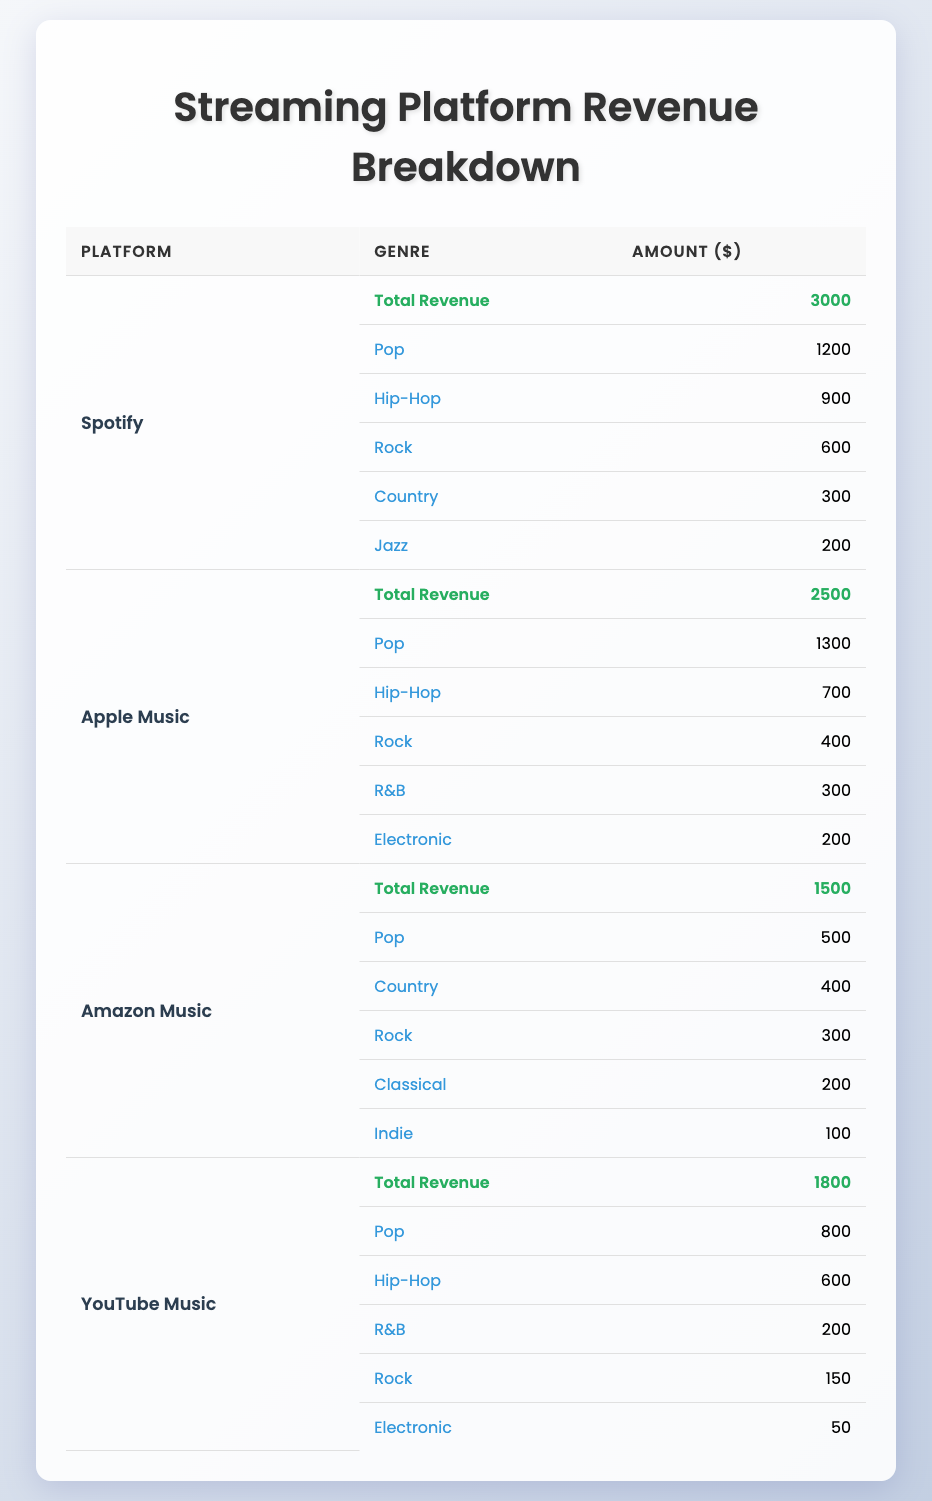What is the total revenue for Spotify? The total revenue for Spotify is listed in the table under the "Total Revenue" row. By checking that specific entry, we see it is 3000.
Answer: 3000 Which platform has the highest revenue from the Pop genre? To find out which platform has the highest revenue for Pop, we compare the Pop revenue figures across all platforms: Spotify (1200), Apple Music (1300), Amazon Music (500), and YouTube Music (800). Apple Music has the highest with 1300.
Answer: Apple Music Is the revenue from Hip-Hop higher on Spotify than on Apple Music? We look at the Hip-Hop revenue figures for both platforms. Spotify earns 900 from Hip-Hop, while Apple Music earns 700. Since 900 is greater than 700, the statement is true.
Answer: Yes What is the total revenue from Rock across all platforms? We need to sum the Rock revenues from each platform: Spotify (600), Apple Music (400), Amazon Music (300), and YouTube Music (150). Adding these gives us 600 + 400 + 300 + 150 = 1450.
Answer: 1450 Does Amazon Music earn more from Country than from Indie? We check the Country revenue (400) and Indie revenue (100) for Amazon Music. Since 400 is greater than 100, the answer is true.
Answer: Yes What is the average revenue generated from the R&B genre across the streaming platforms? The R&B revenue figures are: Apple Music (300) and YouTube Music (200). We add them: 300 + 200 = 500, then divide by the number of platforms (2) to find the average: 500 / 2 = 250.
Answer: 250 Which genre has the lowest revenue on YouTube Music? We look at the YouTube Music genres: Pop (800), Hip-Hop (600), R&B (200), Rock (150), and Electronic (50). The lowest revenue is from the Electronic genre at 50.
Answer: Electronic What is the difference in total revenue between Spotify and Amazon Music? The total revenue for Spotify is 3000 and for Amazon Music is 1500. To find the difference, we subtract: 3000 - 1500 = 1500.
Answer: 1500 How much revenue does Apple Music generate from Electronic compared to Jazz from Spotify? The Electronic revenue from Apple Music is 200, while the Jazz revenue from Spotify is 200 as well. Since both are equal, the comparison shows they generate the same amount.
Answer: Equal 